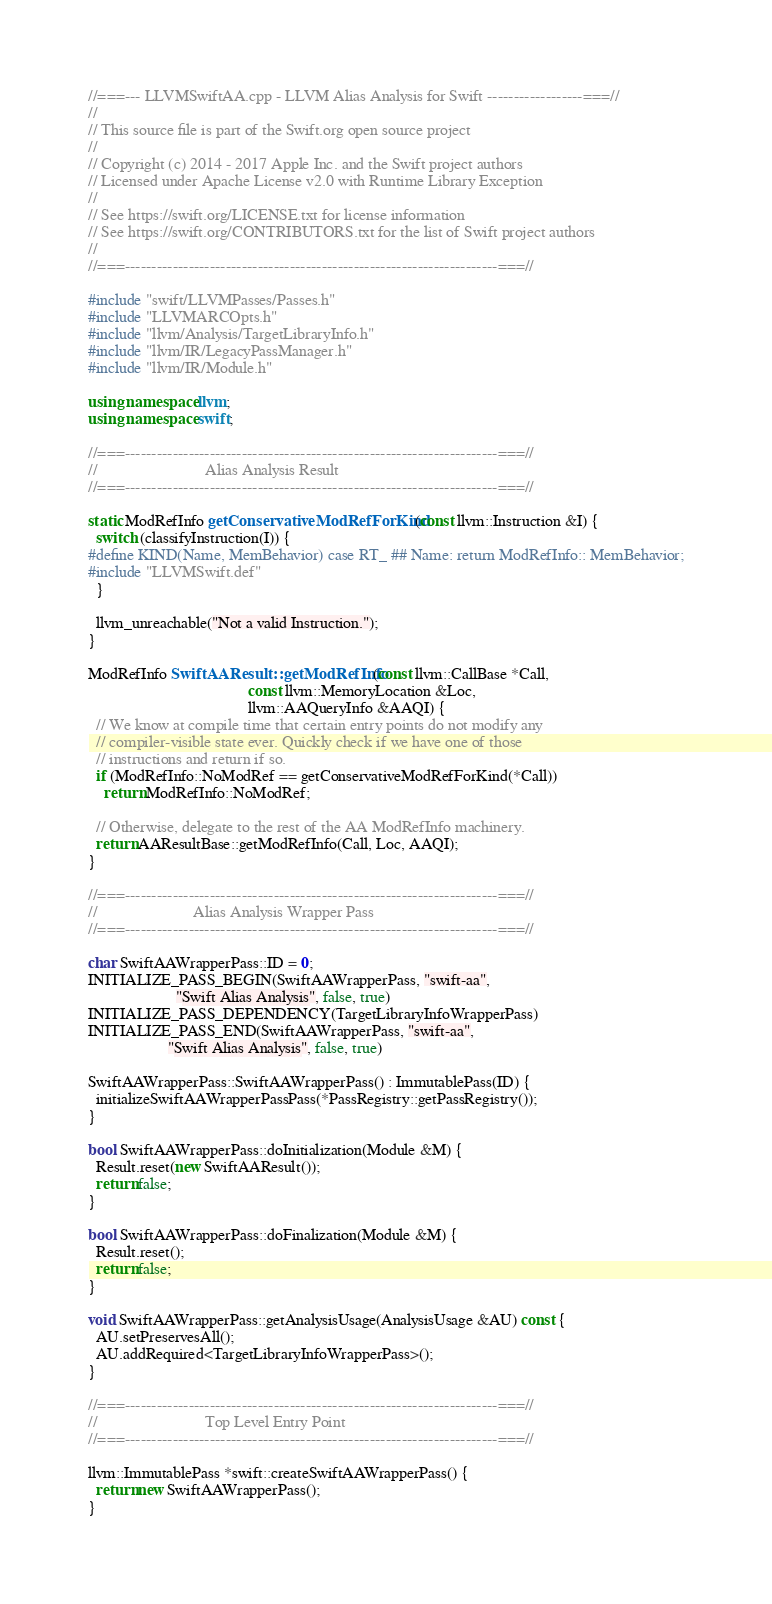<code> <loc_0><loc_0><loc_500><loc_500><_C++_>//===--- LLVMSwiftAA.cpp - LLVM Alias Analysis for Swift ------------------===//
//
// This source file is part of the Swift.org open source project
//
// Copyright (c) 2014 - 2017 Apple Inc. and the Swift project authors
// Licensed under Apache License v2.0 with Runtime Library Exception
//
// See https://swift.org/LICENSE.txt for license information
// See https://swift.org/CONTRIBUTORS.txt for the list of Swift project authors
//
//===----------------------------------------------------------------------===//

#include "swift/LLVMPasses/Passes.h"
#include "LLVMARCOpts.h"
#include "llvm/Analysis/TargetLibraryInfo.h"
#include "llvm/IR/LegacyPassManager.h" 
#include "llvm/IR/Module.h"

using namespace llvm;
using namespace swift;

//===----------------------------------------------------------------------===//
//                           Alias Analysis Result
//===----------------------------------------------------------------------===//

static ModRefInfo getConservativeModRefForKind(const llvm::Instruction &I) {
  switch (classifyInstruction(I)) {
#define KIND(Name, MemBehavior) case RT_ ## Name: return ModRefInfo:: MemBehavior;
#include "LLVMSwift.def"
  }

  llvm_unreachable("Not a valid Instruction.");
}

ModRefInfo SwiftAAResult::getModRefInfo(const llvm::CallBase *Call,
                                        const llvm::MemoryLocation &Loc,
                                        llvm::AAQueryInfo &AAQI) {
  // We know at compile time that certain entry points do not modify any
  // compiler-visible state ever. Quickly check if we have one of those
  // instructions and return if so.
  if (ModRefInfo::NoModRef == getConservativeModRefForKind(*Call))
    return ModRefInfo::NoModRef;

  // Otherwise, delegate to the rest of the AA ModRefInfo machinery.
  return AAResultBase::getModRefInfo(Call, Loc, AAQI);
}

//===----------------------------------------------------------------------===//
//                        Alias Analysis Wrapper Pass
//===----------------------------------------------------------------------===//

char SwiftAAWrapperPass::ID = 0;
INITIALIZE_PASS_BEGIN(SwiftAAWrapperPass, "swift-aa",
                      "Swift Alias Analysis", false, true)
INITIALIZE_PASS_DEPENDENCY(TargetLibraryInfoWrapperPass)
INITIALIZE_PASS_END(SwiftAAWrapperPass, "swift-aa",
                    "Swift Alias Analysis", false, true)

SwiftAAWrapperPass::SwiftAAWrapperPass() : ImmutablePass(ID) {
  initializeSwiftAAWrapperPassPass(*PassRegistry::getPassRegistry());
}

bool SwiftAAWrapperPass::doInitialization(Module &M) {
  Result.reset(new SwiftAAResult());
  return false;
}

bool SwiftAAWrapperPass::doFinalization(Module &M) {
  Result.reset();
  return false;
}

void SwiftAAWrapperPass::getAnalysisUsage(AnalysisUsage &AU) const {
  AU.setPreservesAll();
  AU.addRequired<TargetLibraryInfoWrapperPass>();
}

//===----------------------------------------------------------------------===//
//                           Top Level Entry Point
//===----------------------------------------------------------------------===//

llvm::ImmutablePass *swift::createSwiftAAWrapperPass() {
  return new SwiftAAWrapperPass();
}
</code> 